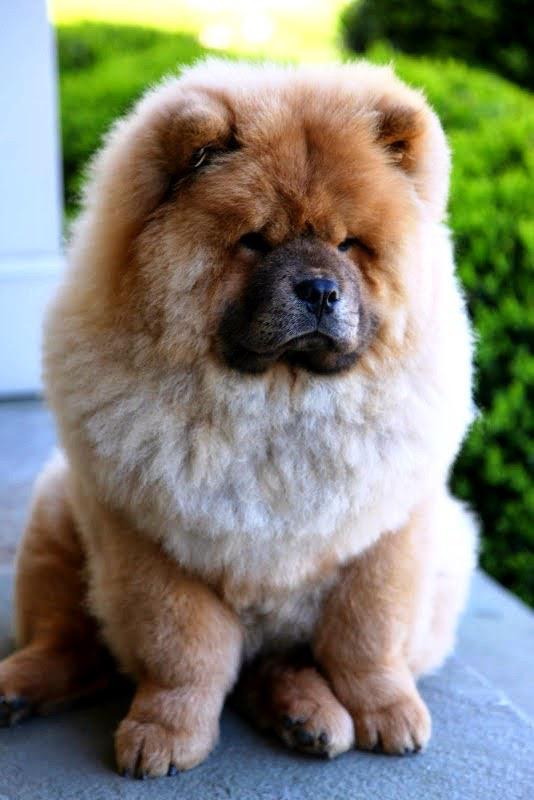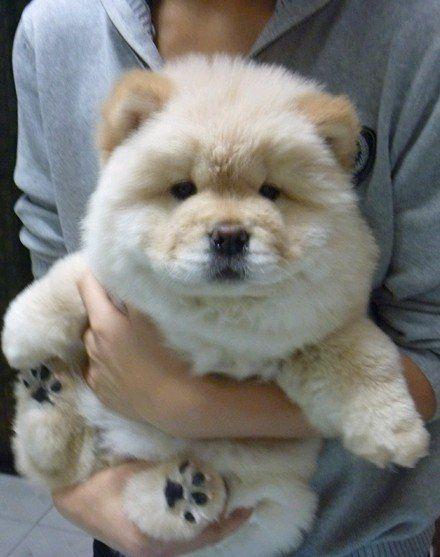The first image is the image on the left, the second image is the image on the right. Evaluate the accuracy of this statement regarding the images: "A dog is laying in grass.". Is it true? Answer yes or no. No. The first image is the image on the left, the second image is the image on the right. For the images displayed, is the sentence "The left and right image contains the same number of dogs with one being held in a woman's arms." factually correct? Answer yes or no. Yes. 